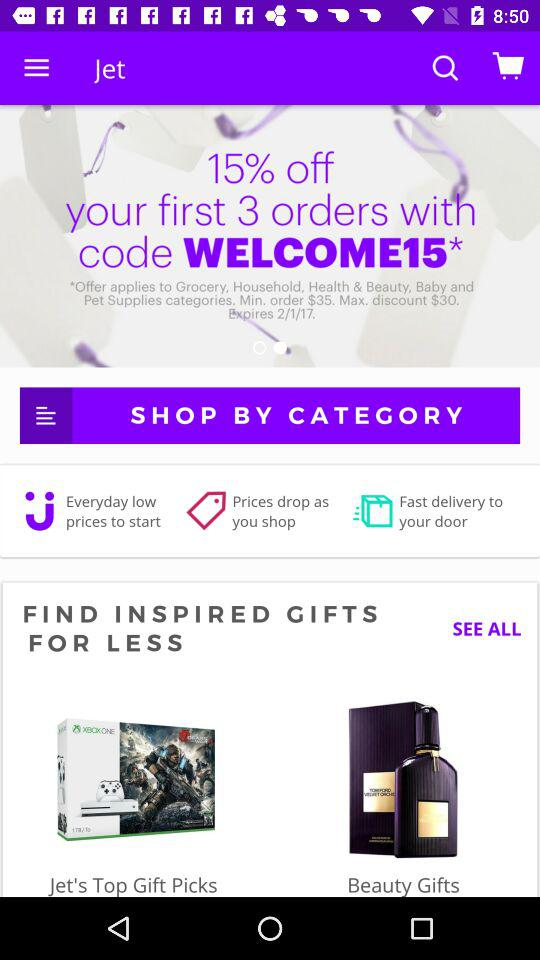How much is the maximum discount? The maximum discount is $30. 